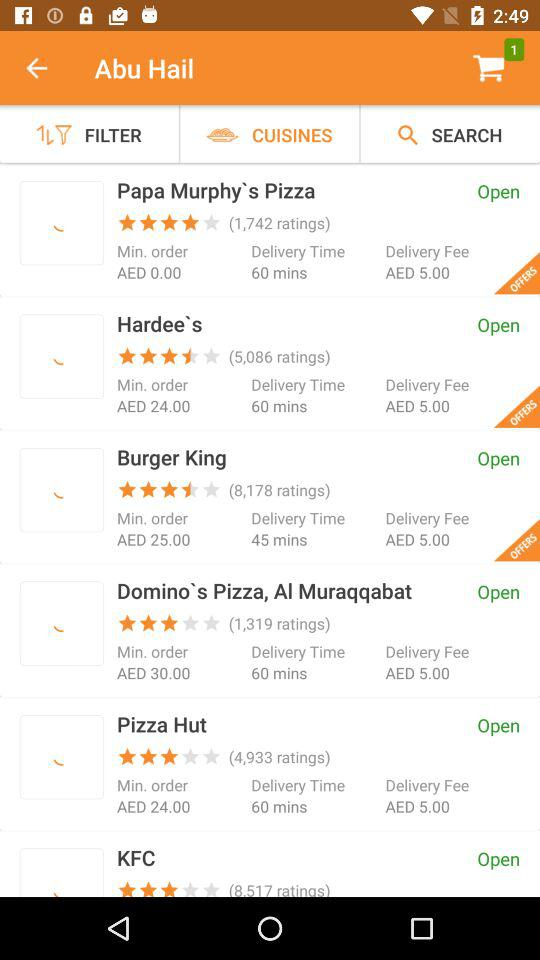What is the minimum order value for "Hardee`s"? The minimum order value is 24 AED. 